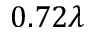<formula> <loc_0><loc_0><loc_500><loc_500>0 . 7 2 \lambda</formula> 